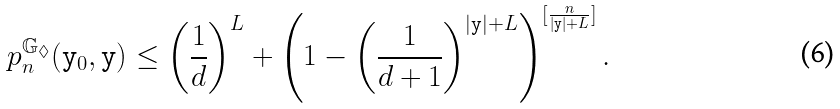<formula> <loc_0><loc_0><loc_500><loc_500>p ^ { { \mathbb { G } } _ { \lozenge } } _ { n } ( { \mathtt y } _ { 0 } , { \mathtt y } ) \leq \left ( \frac { 1 } { d } \right ) ^ { L } + \left ( 1 - \left ( \frac { 1 } { d + 1 } \right ) ^ { | { \mathtt y } | + L } \right ) ^ { [ \frac { n } { | { \mathtt y } | + L } ] } .</formula> 